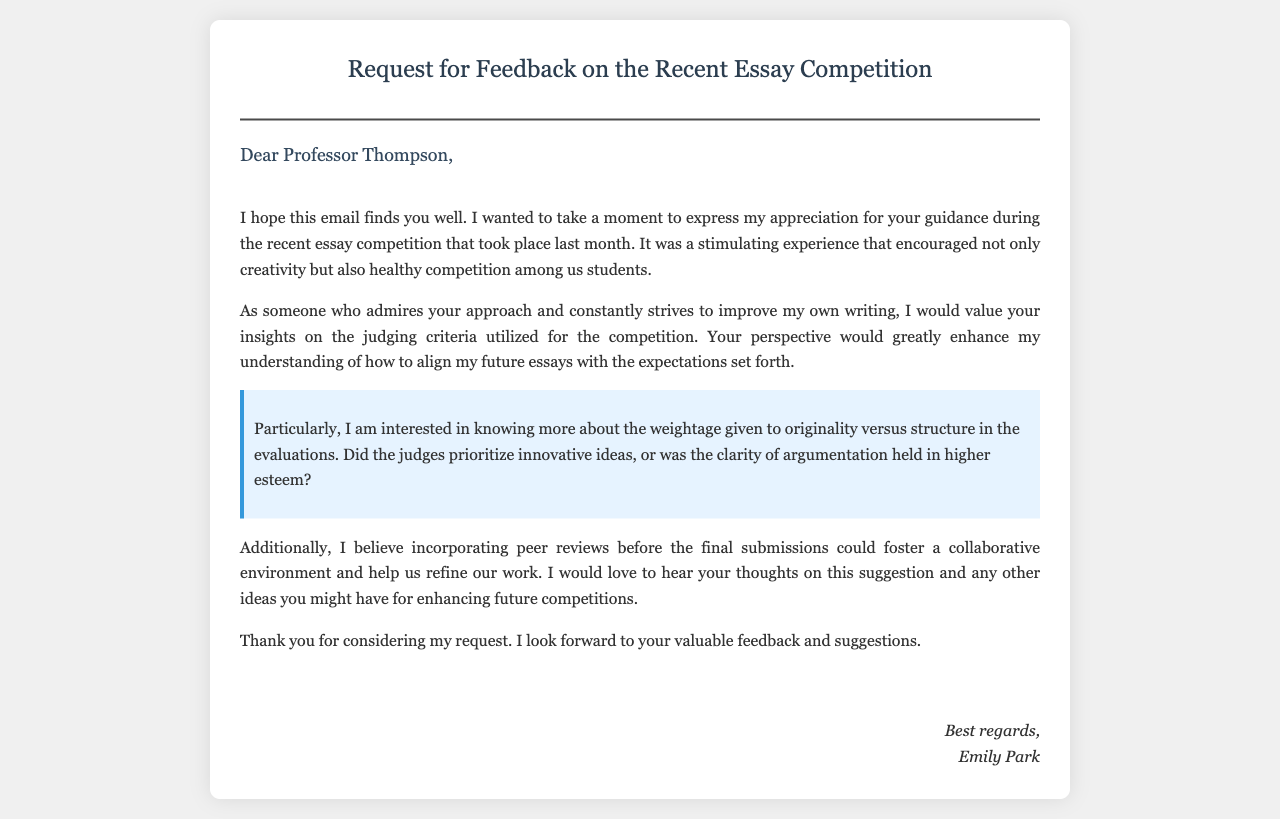What is the title of the email? The title is mentioned prominently at the top of the email container, indicating the subject of the correspondence.
Answer: Request for Feedback on the Recent Essay Competition Who is the email addressed to? The greeting line specifies the recipient of the email by name and title.
Answer: Professor Thompson What is the name of the sender? The signature at the end of the email reveals the identity of the person sending the message.
Answer: Emily Park What is the main purpose of the email? The opening paragraph provides a clear indication of the sender's intent in writing the email.
Answer: Request feedback What specific criteria does Emily ask about? The highlighted section of the email specifically mentions the criteria Emily is inquiring about.
Answer: Originality versus structure What suggestion does Emily make for future competitions? The content of the email outlines Emily's idea to improve future competitions.
Answer: Incorporating peer reviews When did the essay competition take place? The reference in the initial paragraph indicates a timeframe for the event.
Answer: Last month What tone does Emily use in her email? The overall language and choice of words express a specific type of sentiment throughout the email.
Answer: Appreciative 